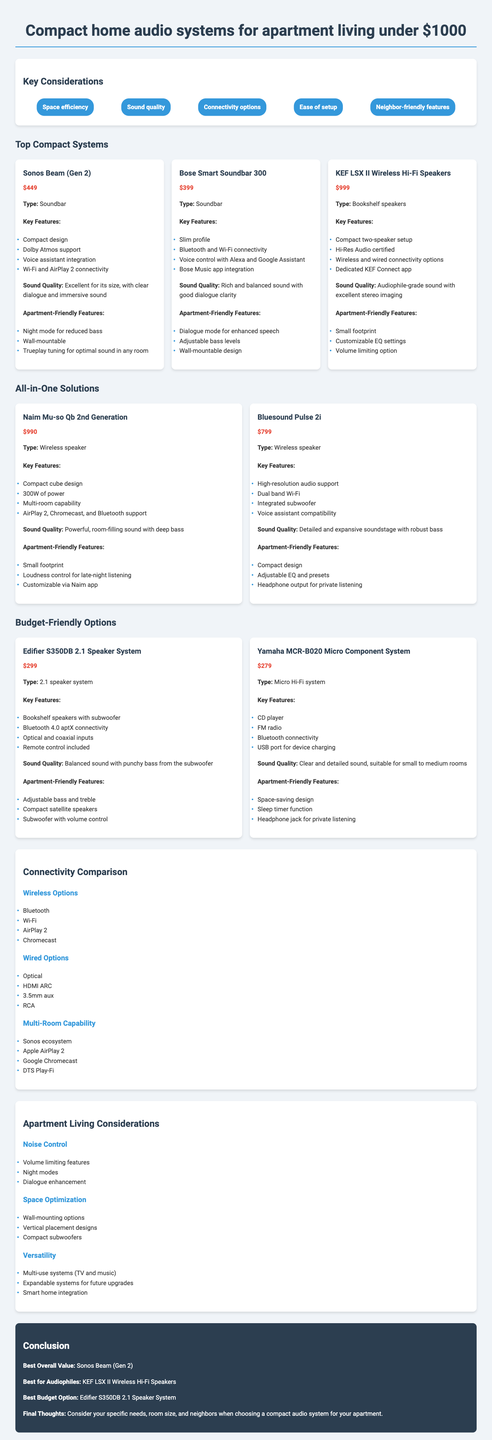what is the price of the Sonos Beam (Gen 2)? The price is listed under the "top compact systems" section next to Sonos Beam (Gen 2).
Answer: $449 what type of system is the KEF LSX II Wireless Hi-Fi Speakers? The type is specified in the product description for KEF LSX II Wireless Hi-Fi Speakers.
Answer: Bookshelf speakers which system is best for audiophiles? This is found in the conclusion section that summarizes the best options.
Answer: KEF LSX II Wireless Hi-Fi Speakers what feature does the Bose Smart Soundbar 300 have for speech enhancement? The feature is listed under "apartment-friendly features" of Bose Smart Soundbar 300.
Answer: Dialogue mode how many wireless options are mentioned in the document? The number of wireless options can be counted from the connectivity comparison section.
Answer: 4 which system has a price of $990? This price is provided in the "all-in-one solutions" section for the specific system.
Answer: Naim Mu-so Qb 2nd Generation what is one noise control feature mentioned? The document discusses features that help with noise control in an apartment setting.
Answer: Volume limiting features what is the best budget option mentioned in the conclusion? The budget option is stated in the conclusion summarizing the best picks for different categories.
Answer: Edifier S350DB 2.1 Speaker System 